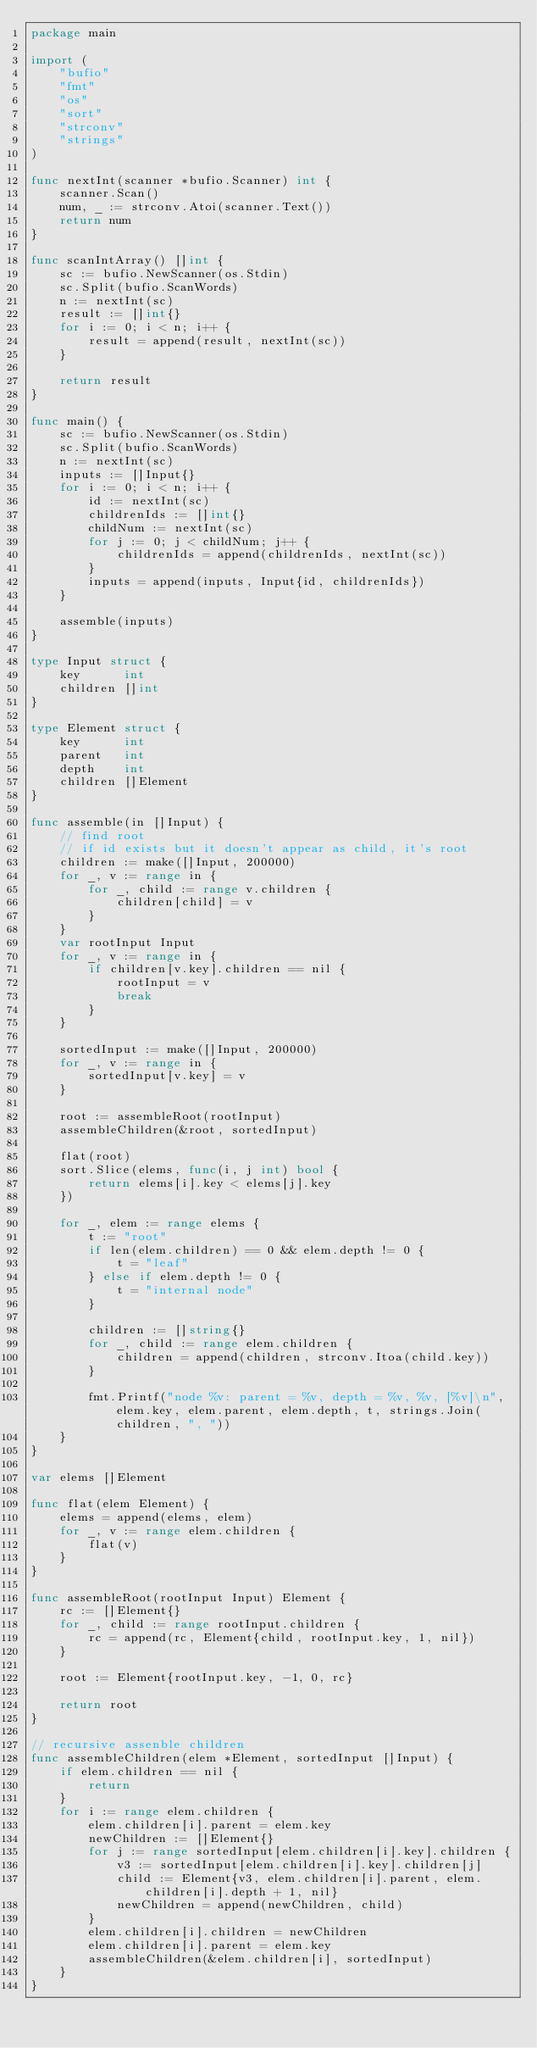Convert code to text. <code><loc_0><loc_0><loc_500><loc_500><_Go_>package main

import (
	"bufio"
	"fmt"
	"os"
	"sort"
	"strconv"
	"strings"
)

func nextInt(scanner *bufio.Scanner) int {
	scanner.Scan()
	num, _ := strconv.Atoi(scanner.Text())
	return num
}

func scanIntArray() []int {
	sc := bufio.NewScanner(os.Stdin)
	sc.Split(bufio.ScanWords)
	n := nextInt(sc)
	result := []int{}
	for i := 0; i < n; i++ {
		result = append(result, nextInt(sc))
	}

	return result
}

func main() {
	sc := bufio.NewScanner(os.Stdin)
	sc.Split(bufio.ScanWords)
	n := nextInt(sc)
	inputs := []Input{}
	for i := 0; i < n; i++ {
		id := nextInt(sc)
		childrenIds := []int{}
		childNum := nextInt(sc)
		for j := 0; j < childNum; j++ {
			childrenIds = append(childrenIds, nextInt(sc))
		}
		inputs = append(inputs, Input{id, childrenIds})
	}

	assemble(inputs)
}

type Input struct {
	key      int
	children []int
}

type Element struct {
	key      int
	parent   int
	depth    int
	children []Element
}

func assemble(in []Input) {
	// find root
	// if id exists but it doesn't appear as child, it's root
	children := make([]Input, 200000)
	for _, v := range in {
		for _, child := range v.children {
			children[child] = v
		}
	}
	var rootInput Input
	for _, v := range in {
		if children[v.key].children == nil {
			rootInput = v
			break
		}
	}

	sortedInput := make([]Input, 200000)
	for _, v := range in {
		sortedInput[v.key] = v
	}

	root := assembleRoot(rootInput)
	assembleChildren(&root, sortedInput)

	flat(root)
	sort.Slice(elems, func(i, j int) bool {
		return elems[i].key < elems[j].key
	})

	for _, elem := range elems {
		t := "root"
		if len(elem.children) == 0 && elem.depth != 0 {
			t = "leaf"
		} else if elem.depth != 0 {
			t = "internal node"
		}

		children := []string{}
		for _, child := range elem.children {
			children = append(children, strconv.Itoa(child.key))
		}

		fmt.Printf("node %v: parent = %v, depth = %v, %v, [%v]\n", elem.key, elem.parent, elem.depth, t, strings.Join(children, ", "))
	}
}

var elems []Element

func flat(elem Element) {
	elems = append(elems, elem)
	for _, v := range elem.children {
		flat(v)
	}
}

func assembleRoot(rootInput Input) Element {
	rc := []Element{}
	for _, child := range rootInput.children {
		rc = append(rc, Element{child, rootInput.key, 1, nil})
	}

	root := Element{rootInput.key, -1, 0, rc}

	return root
}

// recursive assenble children
func assembleChildren(elem *Element, sortedInput []Input) {
	if elem.children == nil {
		return
	}
	for i := range elem.children {
		elem.children[i].parent = elem.key
		newChildren := []Element{}
		for j := range sortedInput[elem.children[i].key].children {
			v3 := sortedInput[elem.children[i].key].children[j]
			child := Element{v3, elem.children[i].parent, elem.children[i].depth + 1, nil}
			newChildren = append(newChildren, child)
		}
		elem.children[i].children = newChildren
		elem.children[i].parent = elem.key
		assembleChildren(&elem.children[i], sortedInput)
	}
}

</code> 